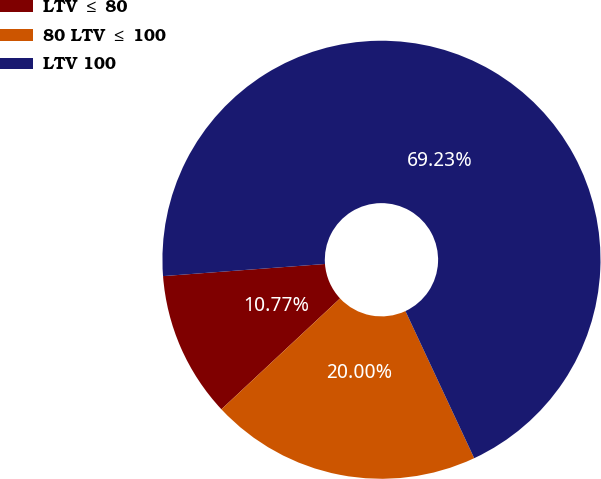Convert chart. <chart><loc_0><loc_0><loc_500><loc_500><pie_chart><fcel>LTV ≤ 80<fcel>80 LTV ≤ 100<fcel>LTV 100<nl><fcel>10.77%<fcel>20.0%<fcel>69.23%<nl></chart> 